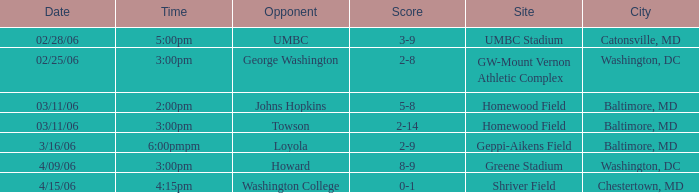Who was the Opponent at Homewood Field with a Score of 5-8? Johns Hopkins. 